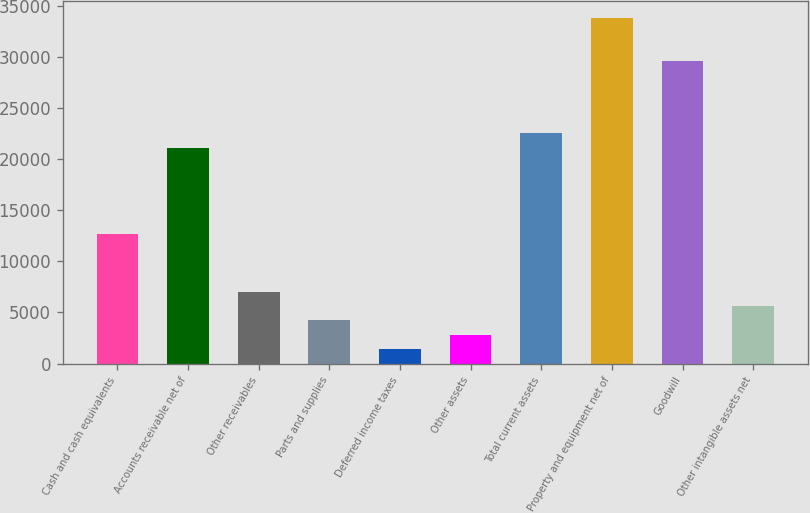<chart> <loc_0><loc_0><loc_500><loc_500><bar_chart><fcel>Cash and cash equivalents<fcel>Accounts receivable net of<fcel>Other receivables<fcel>Parts and supplies<fcel>Deferred income taxes<fcel>Other assets<fcel>Total current assets<fcel>Property and equipment net of<fcel>Goodwill<fcel>Other intangible assets net<nl><fcel>12666.3<fcel>21106.5<fcel>7039.5<fcel>4226.1<fcel>1412.7<fcel>2819.4<fcel>22513.2<fcel>33766.8<fcel>29546.7<fcel>5632.8<nl></chart> 